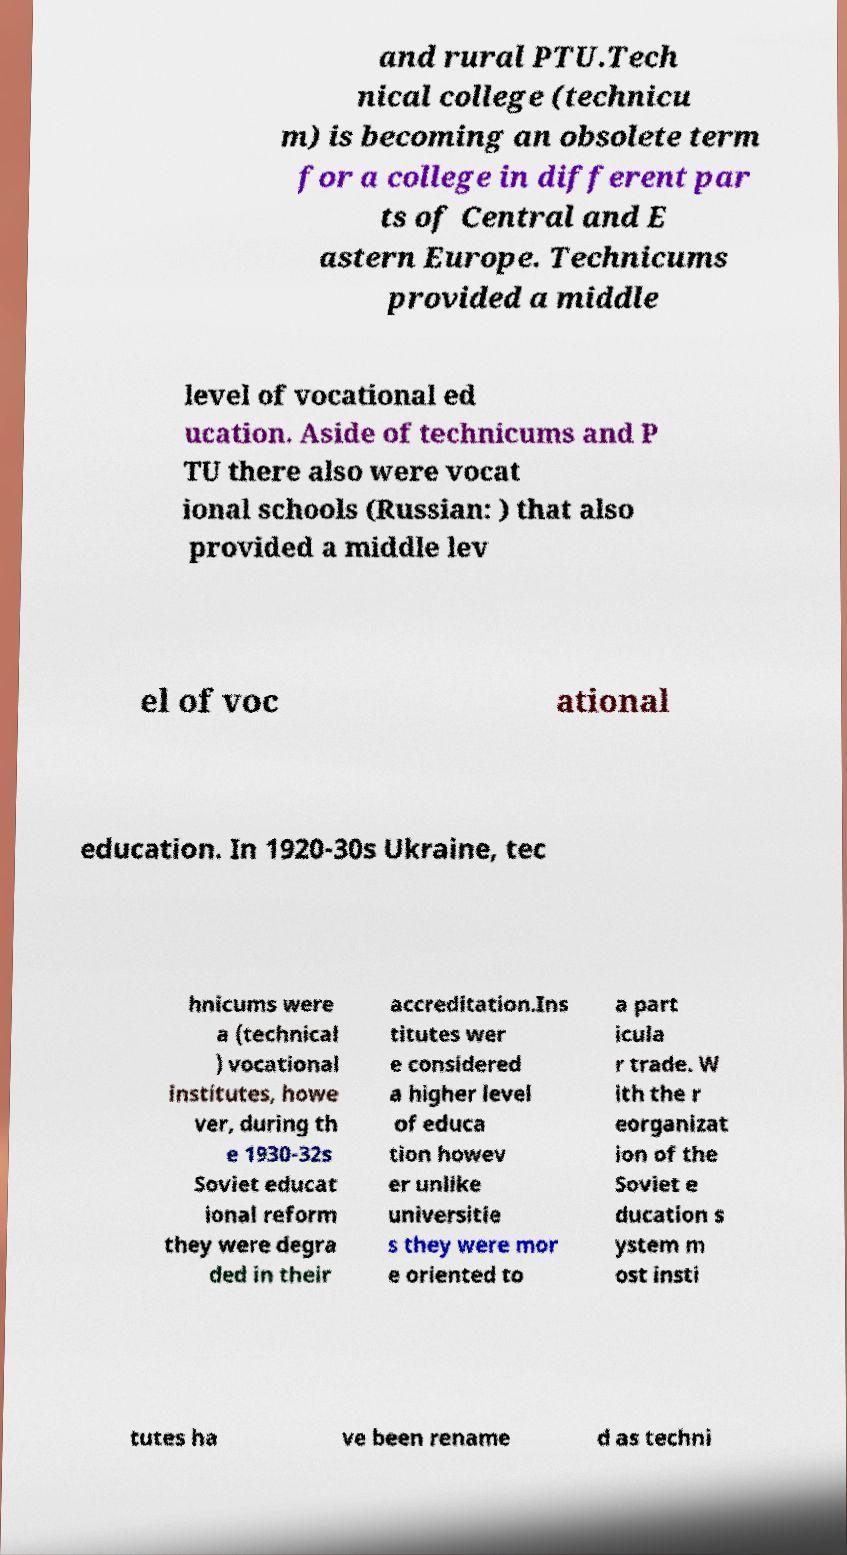Can you read and provide the text displayed in the image?This photo seems to have some interesting text. Can you extract and type it out for me? and rural PTU.Tech nical college (technicu m) is becoming an obsolete term for a college in different par ts of Central and E astern Europe. Technicums provided a middle level of vocational ed ucation. Aside of technicums and P TU there also were vocat ional schools (Russian: ) that also provided a middle lev el of voc ational education. In 1920-30s Ukraine, tec hnicums were a (technical ) vocational institutes, howe ver, during th e 1930-32s Soviet educat ional reform they were degra ded in their accreditation.Ins titutes wer e considered a higher level of educa tion howev er unlike universitie s they were mor e oriented to a part icula r trade. W ith the r eorganizat ion of the Soviet e ducation s ystem m ost insti tutes ha ve been rename d as techni 